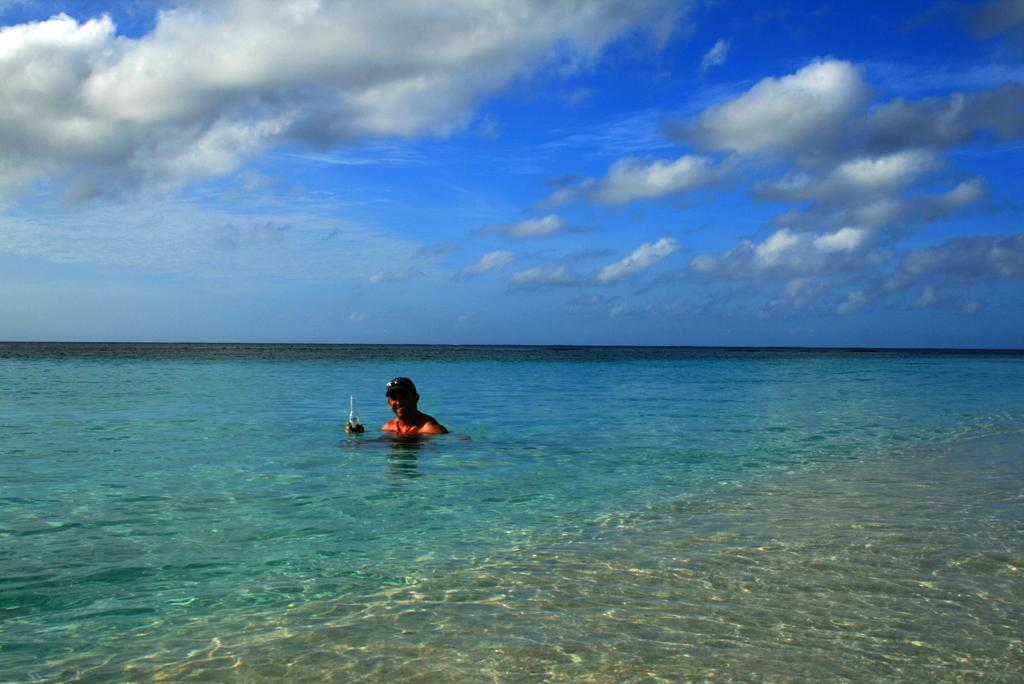What is the person in the image doing? The person is in the water. What object is the person holding in the image? The person is holding a bottle. What can be seen at the top of the image? The sky is visible at the top of the image. How would you describe the sky in the image? The sky appears to be cloudy. What type of plough is being used by the person in the image? There is no plough present in the image; the person is in the water and holding a bottle. 